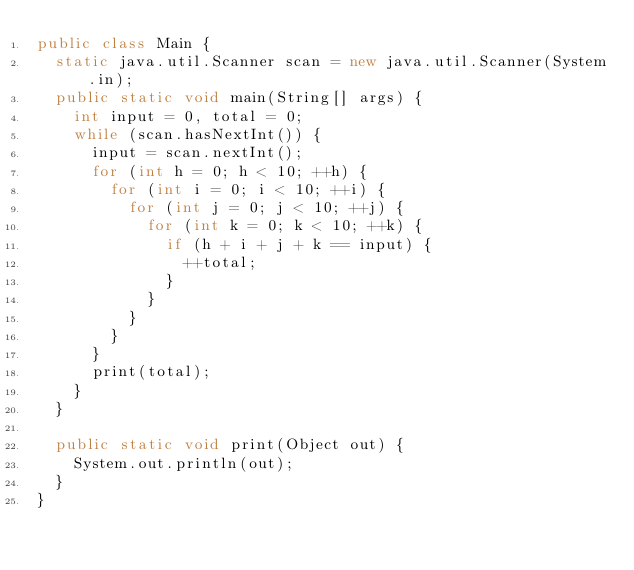<code> <loc_0><loc_0><loc_500><loc_500><_Java_>public class Main {
	static java.util.Scanner scan = new java.util.Scanner(System.in);
	public static void main(String[] args) {
		int input = 0, total = 0;
		while (scan.hasNextInt()) {
			input = scan.nextInt();
			for (int h = 0; h < 10; ++h) {
				for (int i = 0; i < 10; ++i) {
					for (int j = 0; j < 10; ++j) {
						for (int k = 0; k < 10; ++k) {
							if (h + i + j + k == input) {
								++total;
							}
						}
					}
				}
			}
			print(total);
		}
	}
	
	public static void print(Object out) {
		System.out.println(out);
	}
}</code> 